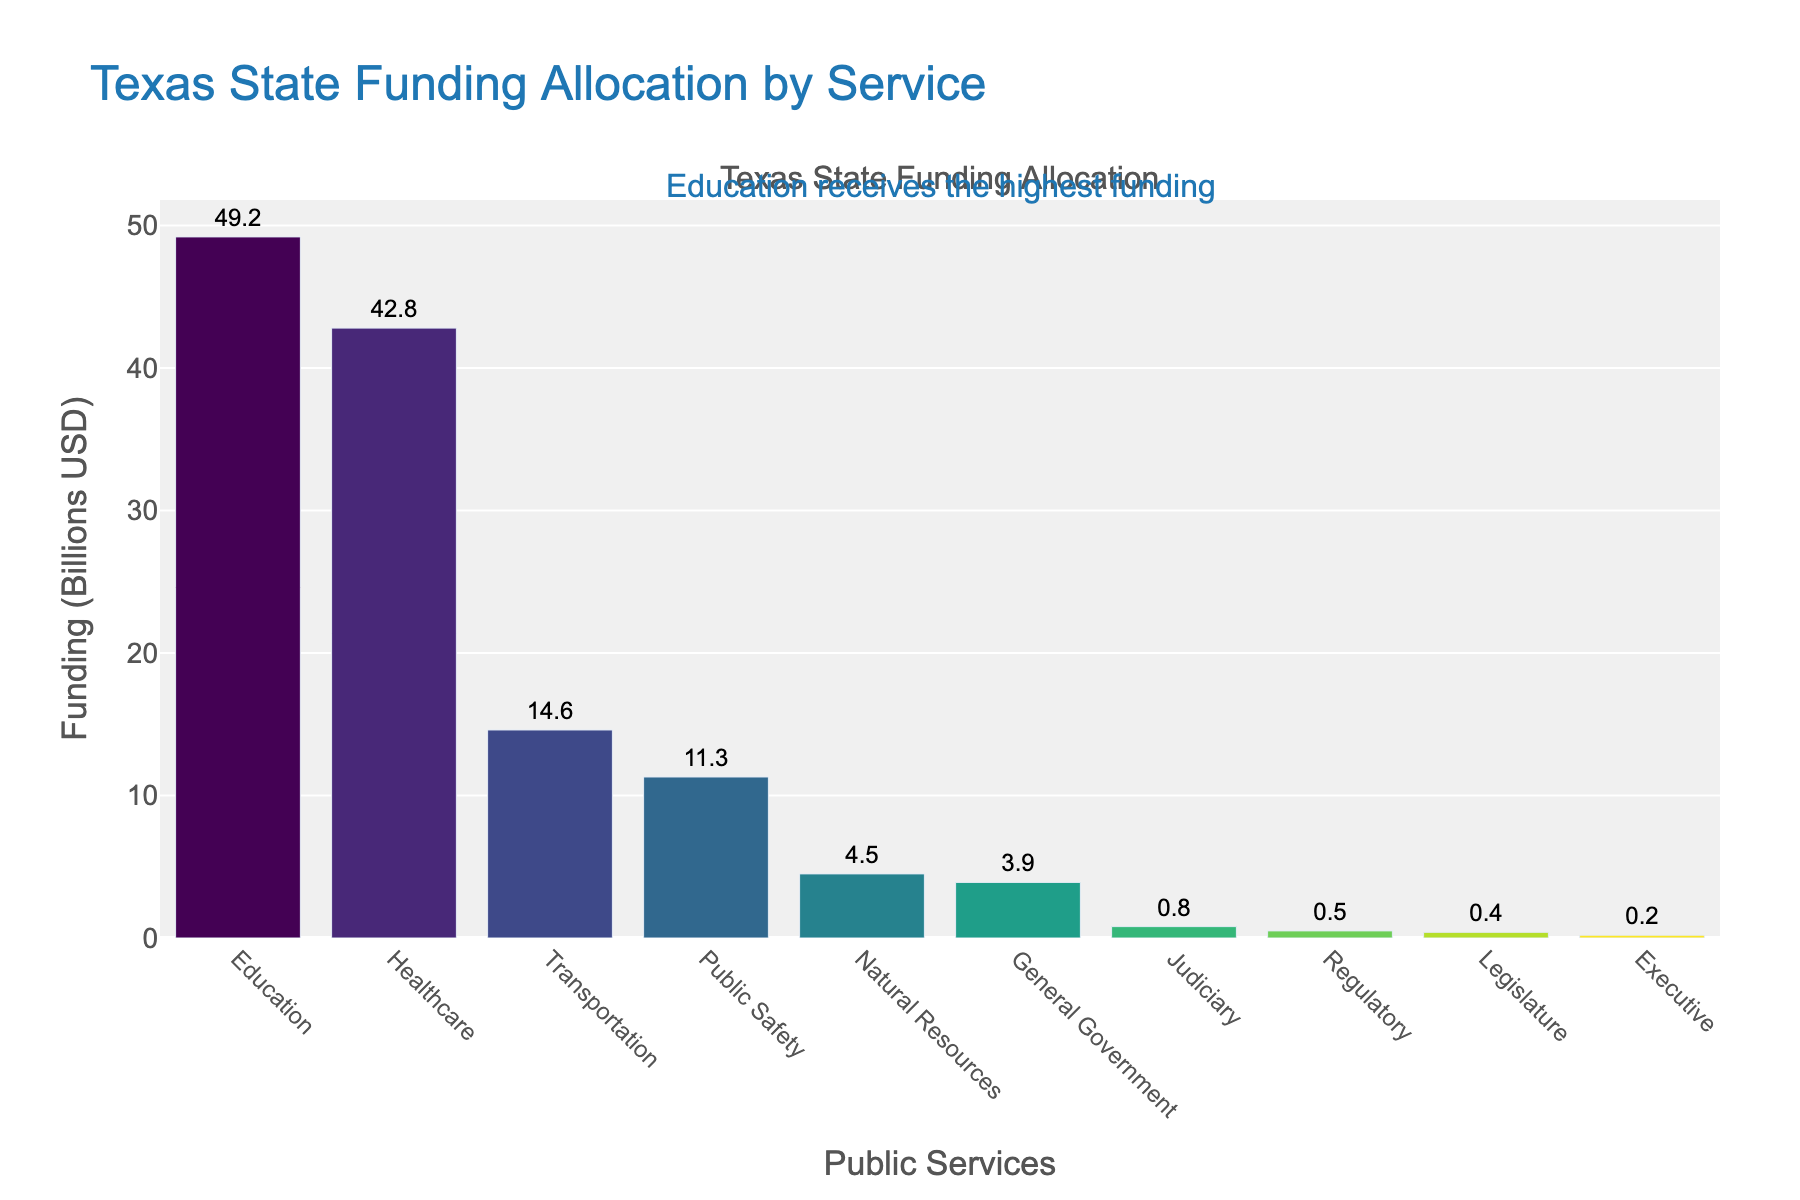What is the total amount of funding allocated for the top three public services? To find the total amount, sum the funding for the top three services: Education ($49.2B), Healthcare ($42.8B), and Transportation ($14.6B). So the total is $49.2B + $42.8B + $14.6B, which equals $106.6B.
Answer: $106.6B Which public service receives more funding, Public Safety or Natural Resources? From the figure, Public Safety receives $11.3B and Natural Resources receives $4.5B. Since $11.3B is greater than $4.5B, Public Safety receives more funding than Natural Resources.
Answer: Public Safety How much more funding does Education receive compared to Transportation? Education receives $49.2B and Transportation receives $14.6B. The difference is calculated as $49.2B - $14.6B, which equals $34.6B.
Answer: $34.6B What is the combined funding for Judiciary, Regulatory, Legislature, and Executive services? Sum the funding for Judiciary ($0.8B), Regulatory ($0.5B), Legislature ($0.4B), and Executive ($0.2B). Adding these gives $0.8B + $0.5B + $0.4B + $0.2B, which equals $1.9B.
Answer: $1.9B Which public service has the fourth highest funding allocation, and what is its amount? The fourth highest funding allocation is for Public Safety with $11.3B.
Answer: Public Safety, $11.3B By how much does the funding for Healthcare exceed the total funding for Public Safety and Natural Resources combined? Healthcare funding is $42.8B. The combined funding for Public Safety and Natural Resources is $11.3B + $4.5B, which equals $15.8B. The excess amount is $42.8B - $15.8B, which equals $27.0B.
Answer: $27.0B What is the difference in funding between the highest and the lowest funded public services? The highest funding is for Education at $49.2B, and the lowest is for Executive at $0.2B. The difference is $49.2B - $0.2B, which equals $49.0B.
Answer: $49.0B How many public services receive funding of less than $5 billion? From the figure, the services receiving less than $5 billion are Natural Resources ($4.5B), General Government ($3.9B), Judiciary ($0.8B), Regulatory ($0.5B), Legislature ($0.4B), and Executive ($0.2B). There are 6 such services.
Answer: 6 